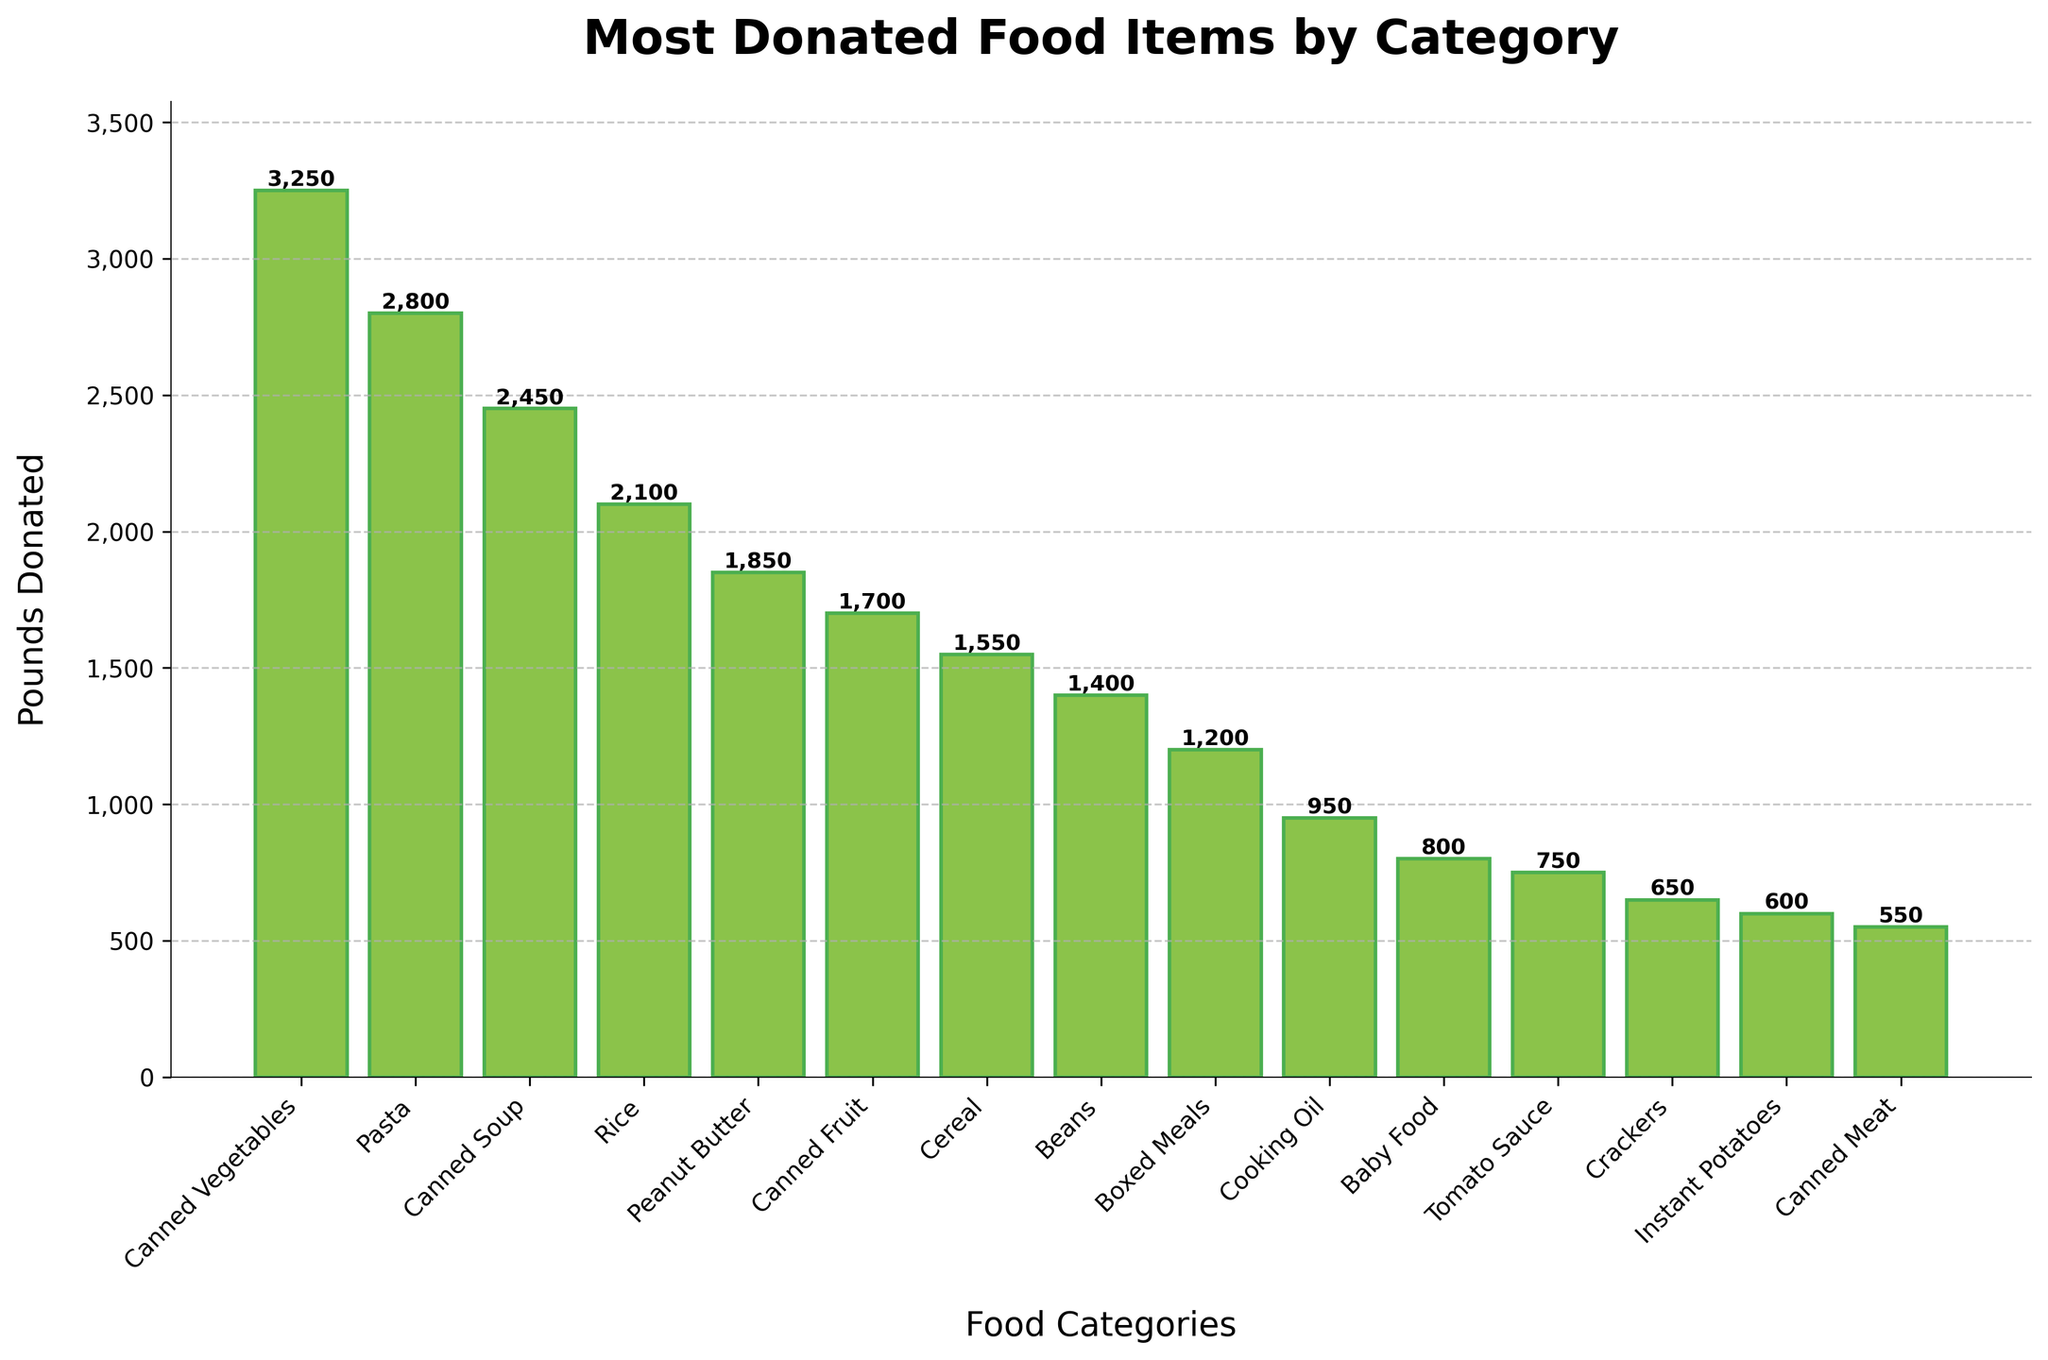Which food category has the highest donation in pounds? The bar chart shows the height of each bar corresponding to the weight in pounds for each food category. The tallest bar represents Canned Vegetables with 3,250 pounds donated.
Answer: Canned Vegetables Which two food categories have donations in pounds closest to each other? By comparing the heights of the bars, we see the bars for Tomato Sauce and Crackers are very close in height, with 750 and 650 pounds donated respectively.
Answer: Tomato Sauce and Crackers What is the total weight of donations for Canned Vegetables and Pasta? Add the weights for Canned Vegetables (3250) and Pasta (2800). The total is 3250 + 2800 = 6050 pounds.
Answer: 6050 pounds How many more pounds of Peanut Butter were donated compared to Cereal? Subtract the pounds donated for Cereal (1550) from that for Peanut Butter (1850). The difference is 1850 - 1550 = 300 pounds.
Answer: 300 pounds Which category has the lowest donation in pounds? The shortest bar represents Canned Meat with 550 pounds donated.
Answer: Canned Meat Are more pounds donated for Boxed Meals or Beans? Comparing the heights of the bars for Boxed Meals (1200 pounds) and Beans (1400 pounds), Beans have more pounds donated.
Answer: Beans What is the average weight of donations for Rice, Peanut Butter, and Canned Soup? Add the weights for Rice (2100), Peanut Butter (1850), and Canned Soup (2450) then divide by 3. The total is 2100 + 1850 + 2450 = 6400 pounds. The average is 6400 / 3 ≈ 2133.33 pounds.
Answer: 2133.33 pounds Which categories have donations that are less than 1000 pounds? Categories with bars less than the 1000-pound mark are Baby Food (800), Tomato Sauce (750), Crackers (650), Instant Potatoes (600), and Canned Meat (550).
Answer: Baby Food, Tomato Sauce, Crackers, Instant Potatoes, Canned Meat How many categories have donations over 2000 pounds? Count the number of bars exceeding the 2000-pound mark. These categories are Canned Vegetables (3250), Pasta (2800), Canned Soup (2450), and Rice (2100), making 4 categories.
Answer: 4 categories What is the combined weight of donations for all Canned items (Canned Vegetables, Canned Soup, Canned Fruit, Canned Meat)? Sum the weights for these categories: Canned Vegetables (3250), Canned Soup (2450), Canned Fruit (1700), and Canned Meat (550). The total is 3250 + 2450 + 1700 + 550 = 7950 pounds.
Answer: 7950 pounds 